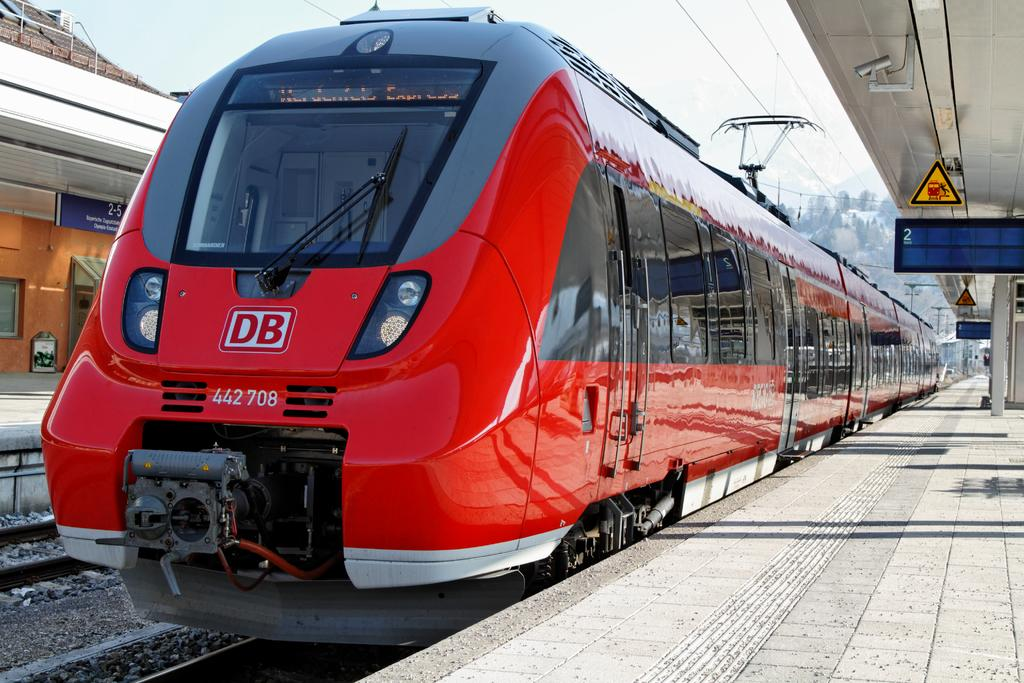<image>
Create a compact narrative representing the image presented. Red train with the call numbers 442 708 waiting at the station. 